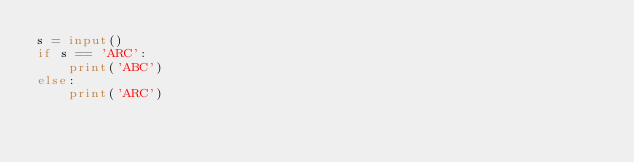<code> <loc_0><loc_0><loc_500><loc_500><_Python_>s = input()
if s == 'ARC':
    print('ABC')
else:
    print('ARC')</code> 